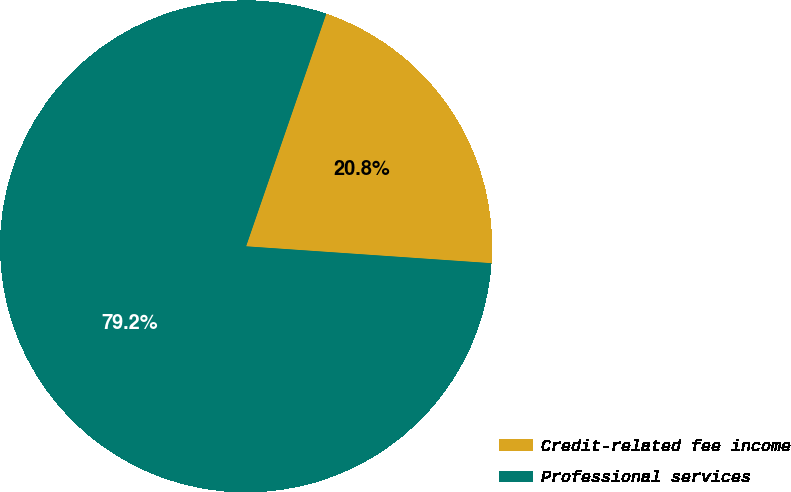Convert chart to OTSL. <chart><loc_0><loc_0><loc_500><loc_500><pie_chart><fcel>Credit-related fee income<fcel>Professional services<nl><fcel>20.81%<fcel>79.19%<nl></chart> 